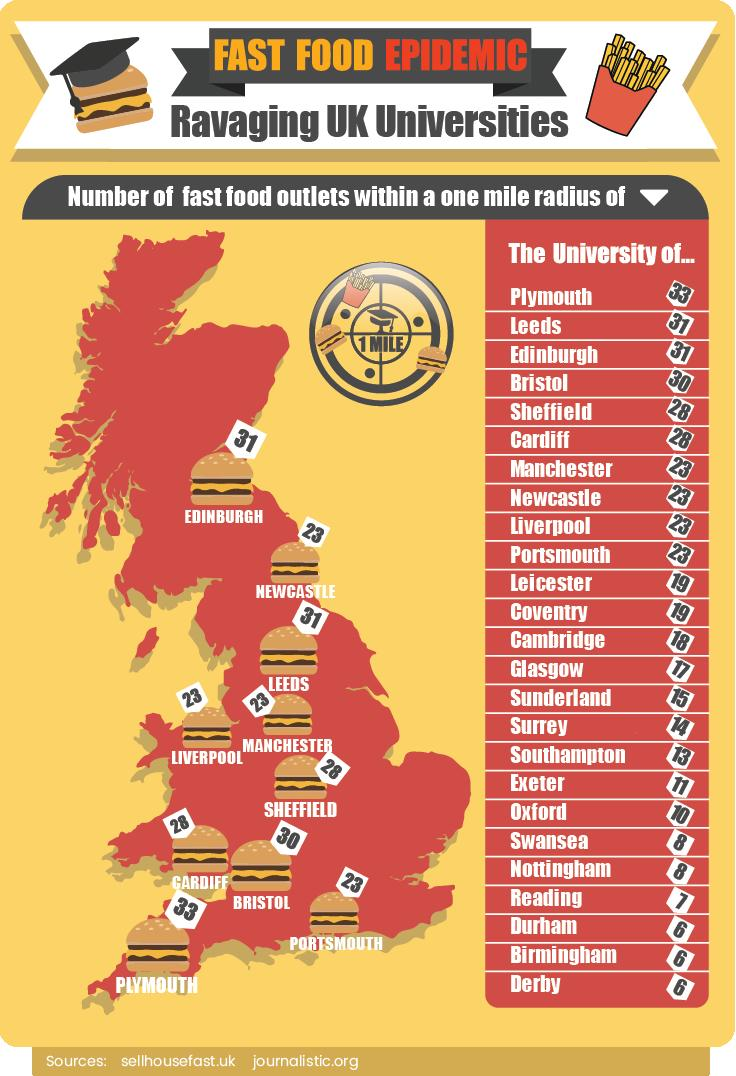Identify some key points in this picture. There are 28 fast food outlets within one mile of many places in the UK. In the United Kingdom, there are places that have six fast food outlets within one mile radius, specifically three of them. The map of the United Kingdom displaying fast food outlets reveals that burgers are the most frequently featured food item, appearing multiple times. In the United Kingdom, there are places other than London that have the second highest number of fast food outlets. Specifically, Leeds and Edinburgh are two examples of cities with a significant number of fast food establishments. There are 2 places in the UK that have 31 or more fast food outlets within a one-mile radius. 